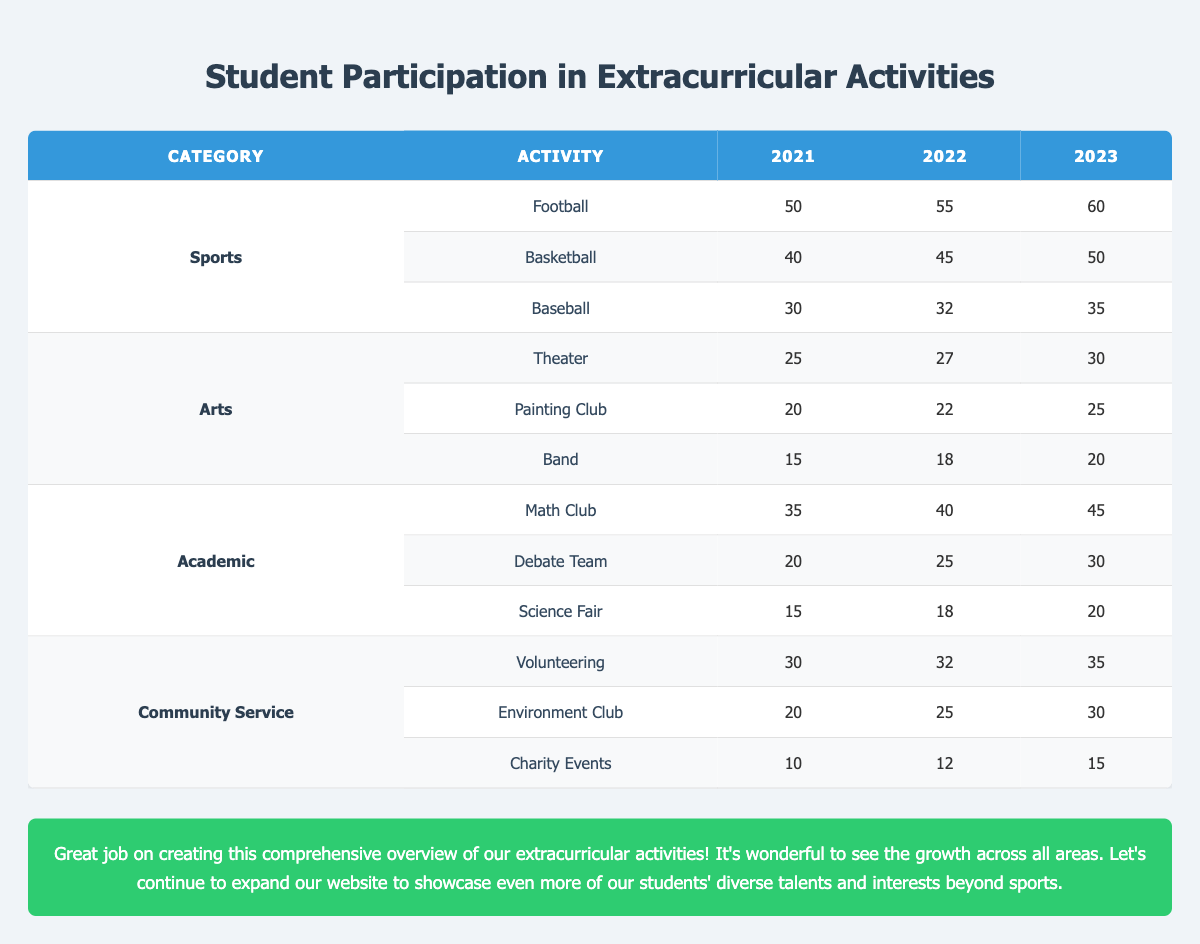What was the most popular sport in 2021? In 2021, Football had the highest participation with 50 students, compared to Basketball with 40 and Baseball with 30.
Answer: Football How many students participated in the Math Club in 2022? In 2022, the participation in the Math Club was 40 students, as indicated in the table under the Academic category.
Answer: 40 What is the change in participation for Baseball from 2021 to 2023? The participation in Baseball increased from 30 in 2021 to 35 in 2023. The change is calculated as 35 - 30 = 5.
Answer: 5 How many students were involved in Extracurricular Activities for Community Service in 2023? In 2023, the total participation in Community Service activities can be found by adding Volunteering (35), Environment Club (30), and Charity Events (15), which totals to 35 + 30 + 15 = 80.
Answer: 80 Did more students participate in Arts or Academic activities in 2021? In 2021, total participation in Arts was 25 + 20 + 15 = 60, while in Academic activities, it was 35 + 20 + 15 = 70, making Academic activities more popular.
Answer: No, Academic activities had more participants What was the average number of participants in the Band from 2021 to 2023? The number of participants in Band from 2021 to 2023 was 15, 18, and 20. The average is calculated as (15 + 18 + 20) / 3 = 53 / 3 = 17.67, which we can round to 18.
Answer: 18 Which Community Service activity saw the highest growth from 2021 to 2023? The Volunteering activity increased from 30 in 2021 to 35 in 2023, a growth of 5. Environment Club grew from 20 to 30, which is a growth of 10. Charity Events grew from 10 to 15, which is a growth of 5. Therefore, Environment Club had the highest growth of 10.
Answer: Environment Club What was the total participation in Academic activities for all three years combined? The total for Academic activities is calculated as follows: (Math Club: 35 + 40 + 45) + (Debate Team: 20 + 25 + 30) + (Science Fair: 15 + 18 + 20) = (120 + 75 + 53) = 248 students.
Answer: 248 In which year did the highest number of students participate in the Painting Club? Referring to the table, the participation in the Painting Club was 20 in 2021, 22 in 2022, and 25 in 2023. Thus, 2023 had the highest number of participants.
Answer: 2023 What percentage of students in the Debate Team participated in 2023 compared to 2021? The participation in the Debate Team was 20 in 2021 and 30 in 2023. The percentage increase is calculated as ((30 - 20) / 20) * 100 = 50%.
Answer: 50% 